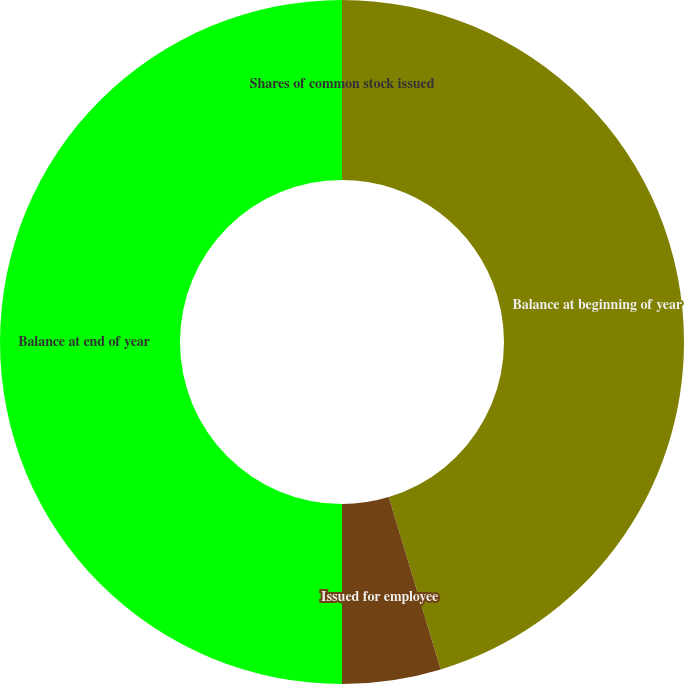<chart> <loc_0><loc_0><loc_500><loc_500><pie_chart><fcel>Shares of common stock issued<fcel>Balance at beginning of year<fcel>Issued for employee<fcel>Balance at end of year<nl><fcel>0.0%<fcel>45.34%<fcel>4.66%<fcel>50.0%<nl></chart> 